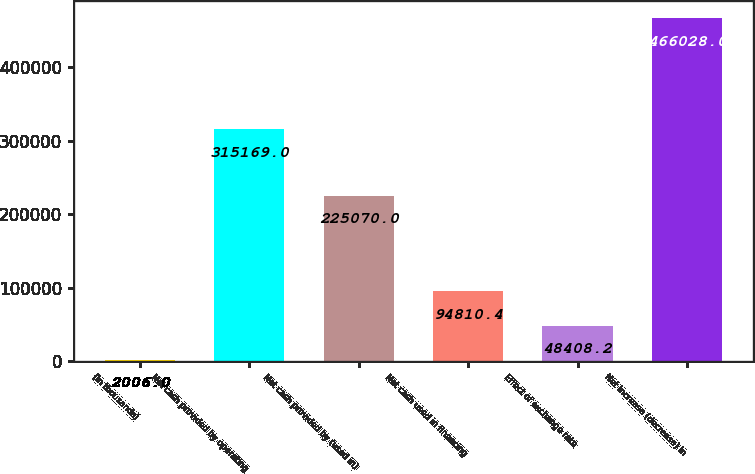Convert chart to OTSL. <chart><loc_0><loc_0><loc_500><loc_500><bar_chart><fcel>(in thousands)<fcel>Net cash provided by operating<fcel>Net cash provided by (used in)<fcel>Net cash used in financing<fcel>Effect of exchange rate<fcel>Net increase (decrease) in<nl><fcel>2006<fcel>315169<fcel>225070<fcel>94810.4<fcel>48408.2<fcel>466028<nl></chart> 